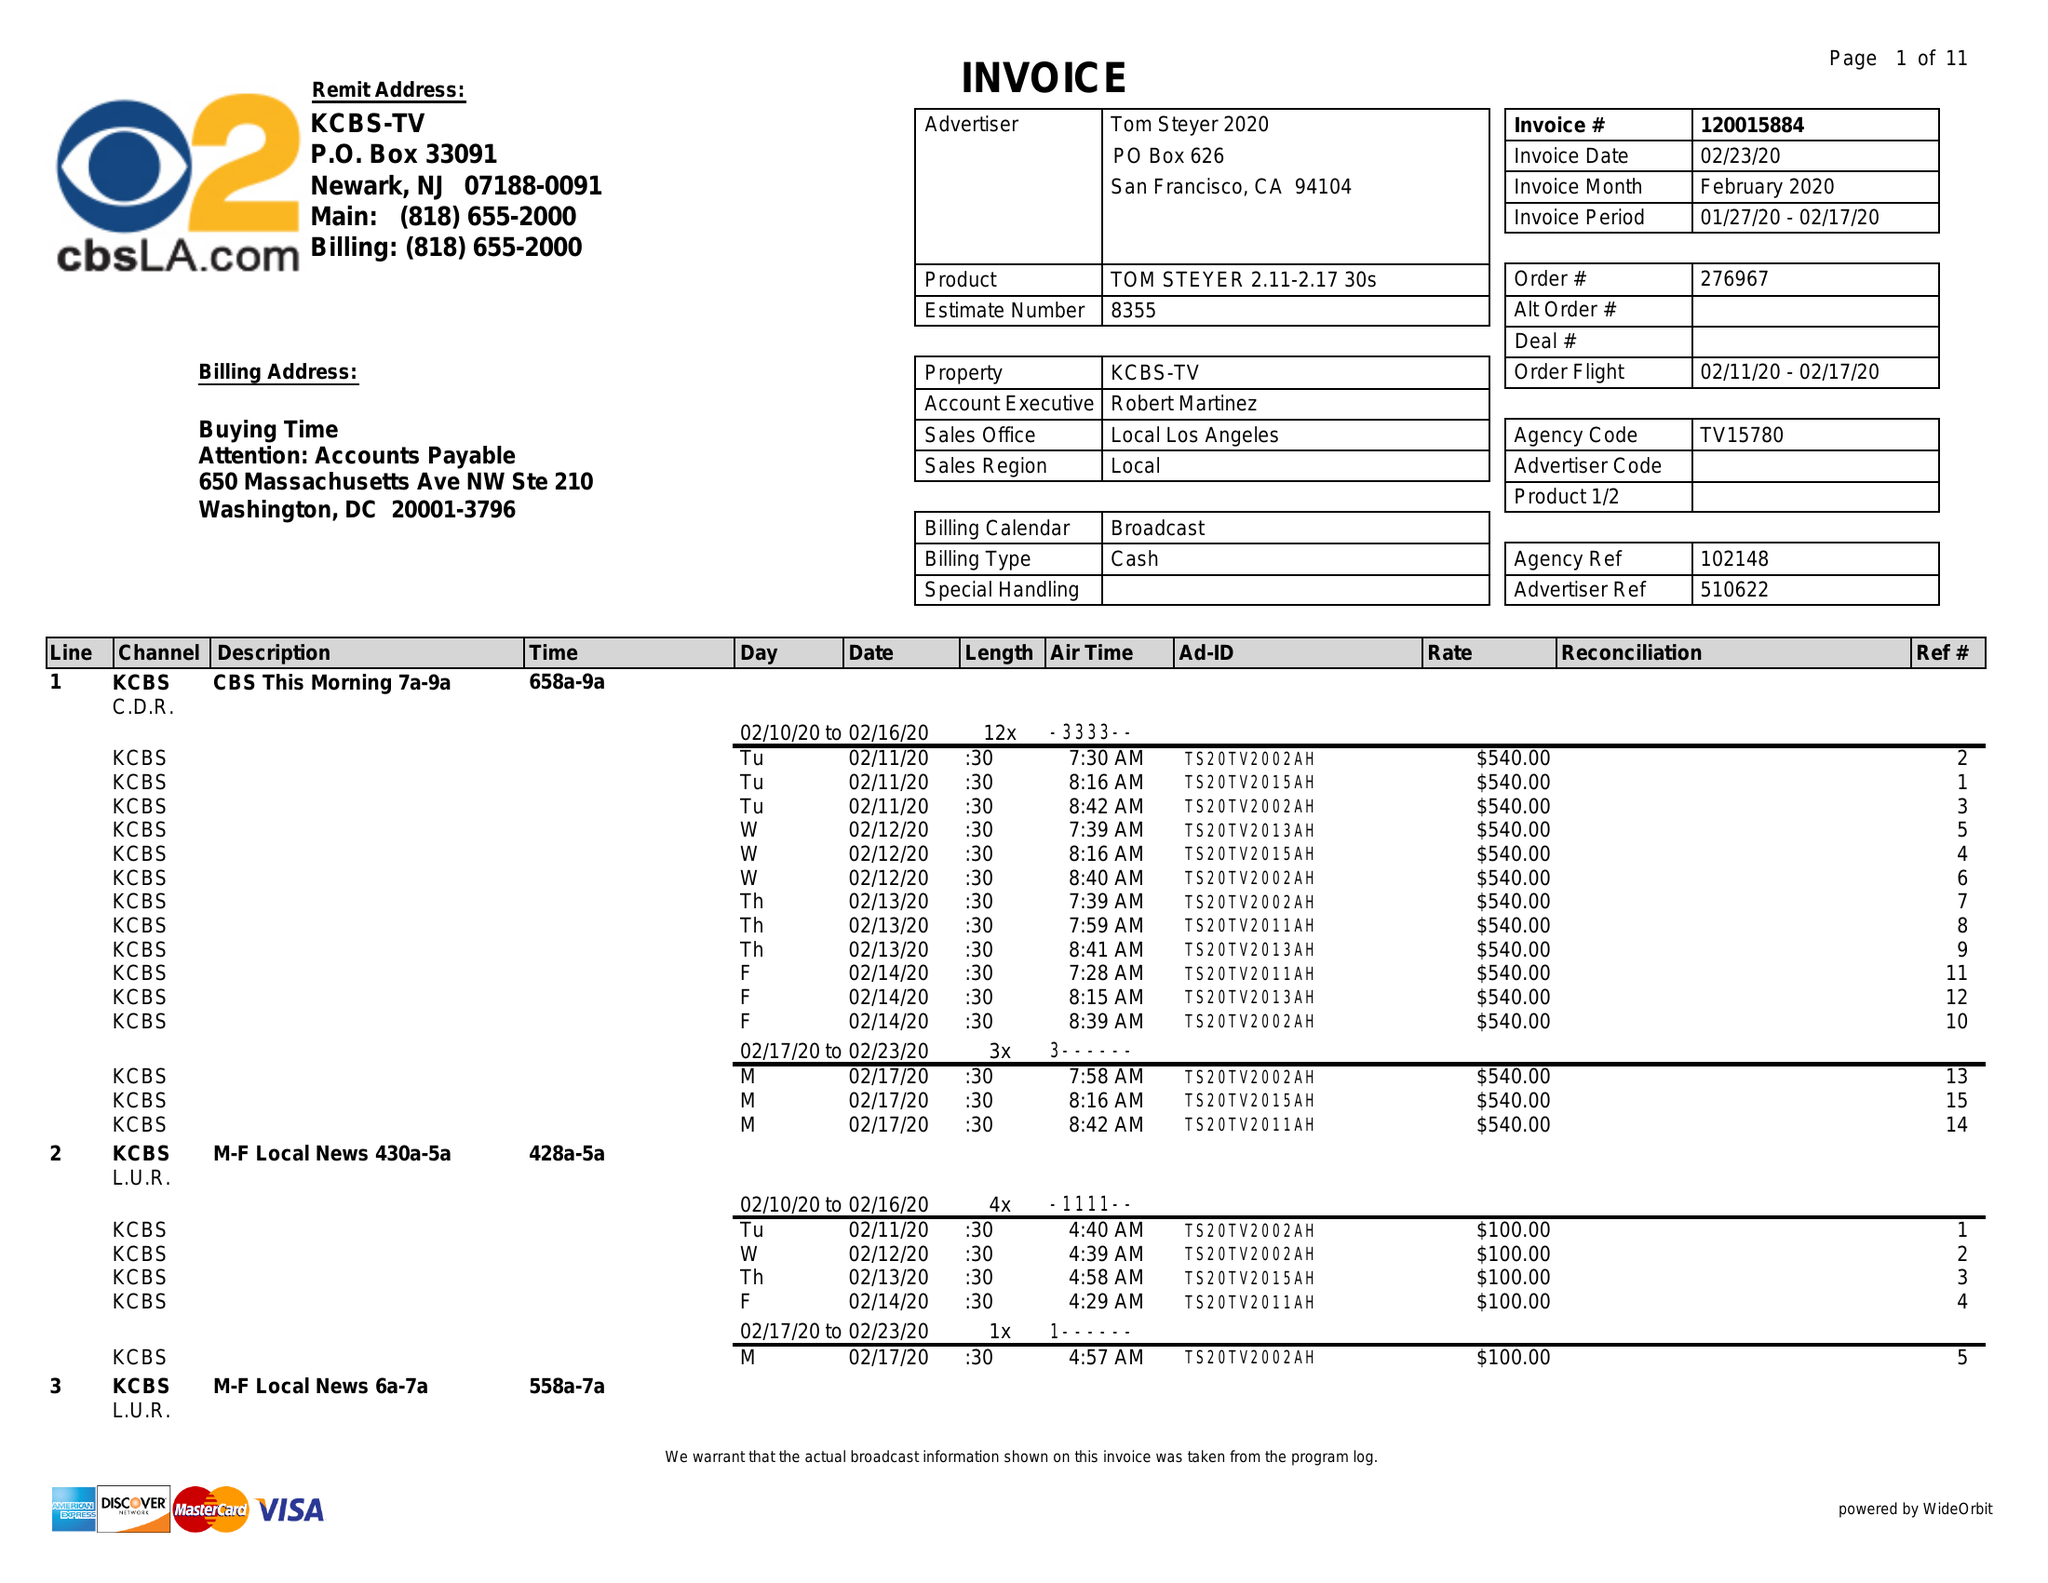What is the value for the advertiser?
Answer the question using a single word or phrase. TOM STEYER 2020 